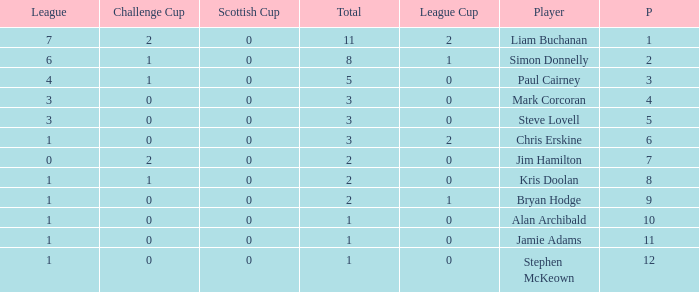How many points did player 7 score in the challenge cup? 1.0. 